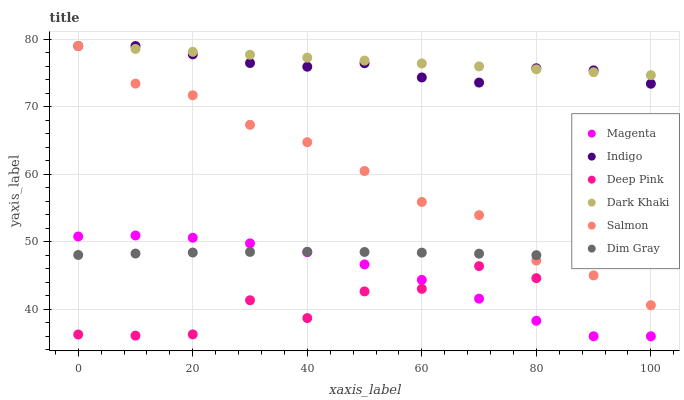Does Deep Pink have the minimum area under the curve?
Answer yes or no. Yes. Does Dark Khaki have the maximum area under the curve?
Answer yes or no. Yes. Does Indigo have the minimum area under the curve?
Answer yes or no. No. Does Indigo have the maximum area under the curve?
Answer yes or no. No. Is Dark Khaki the smoothest?
Answer yes or no. Yes. Is Deep Pink the roughest?
Answer yes or no. Yes. Is Indigo the smoothest?
Answer yes or no. No. Is Indigo the roughest?
Answer yes or no. No. Does Magenta have the lowest value?
Answer yes or no. Yes. Does Indigo have the lowest value?
Answer yes or no. No. Does Dark Khaki have the highest value?
Answer yes or no. Yes. Does Dim Gray have the highest value?
Answer yes or no. No. Is Deep Pink less than Indigo?
Answer yes or no. Yes. Is Indigo greater than Magenta?
Answer yes or no. Yes. Does Dim Gray intersect Deep Pink?
Answer yes or no. Yes. Is Dim Gray less than Deep Pink?
Answer yes or no. No. Is Dim Gray greater than Deep Pink?
Answer yes or no. No. Does Deep Pink intersect Indigo?
Answer yes or no. No. 